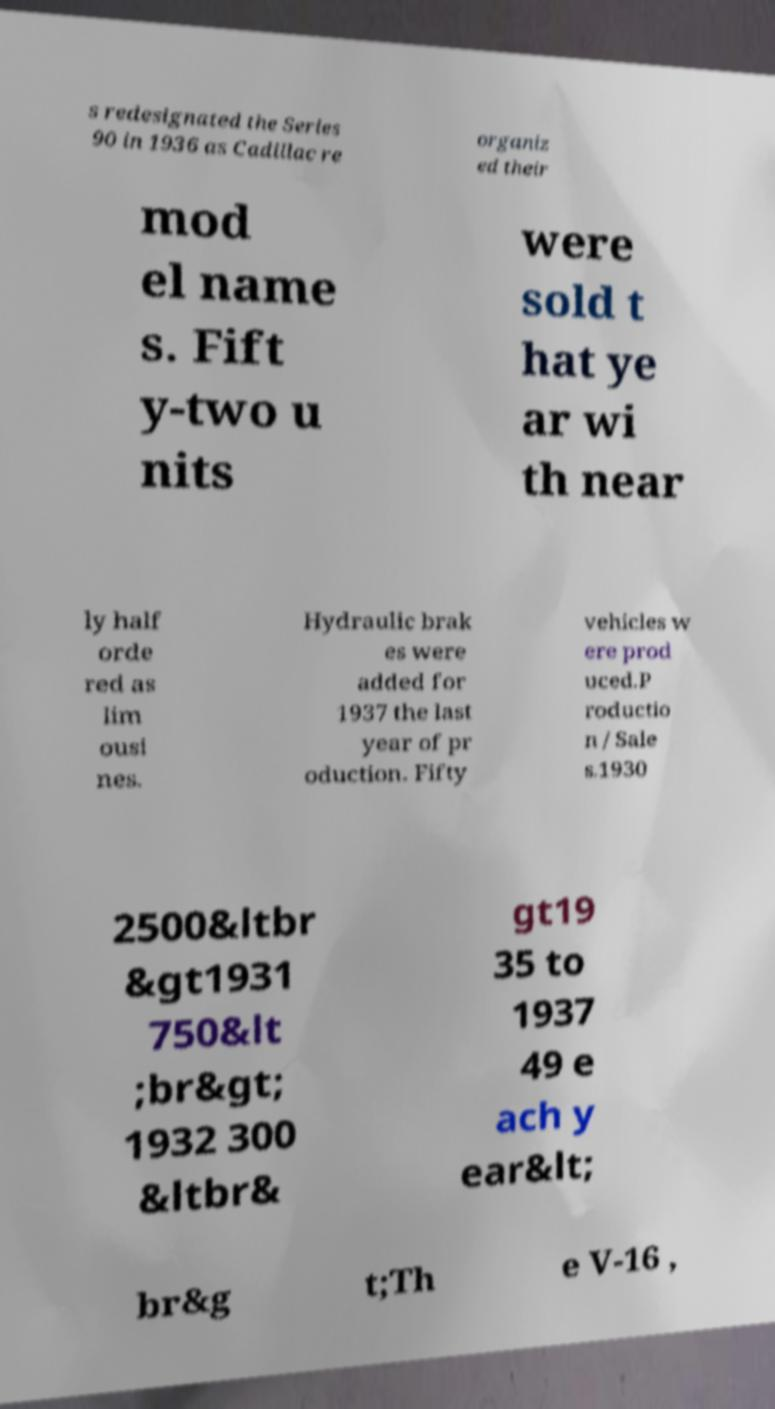Could you assist in decoding the text presented in this image and type it out clearly? s redesignated the Series 90 in 1936 as Cadillac re organiz ed their mod el name s. Fift y-two u nits were sold t hat ye ar wi th near ly half orde red as lim ousi nes. Hydraulic brak es were added for 1937 the last year of pr oduction. Fifty vehicles w ere prod uced.P roductio n / Sale s.1930 2500&ltbr &gt1931 750&lt ;br&gt; 1932 300 &ltbr& gt19 35 to 1937 49 e ach y ear&lt; br&g t;Th e V-16 , 